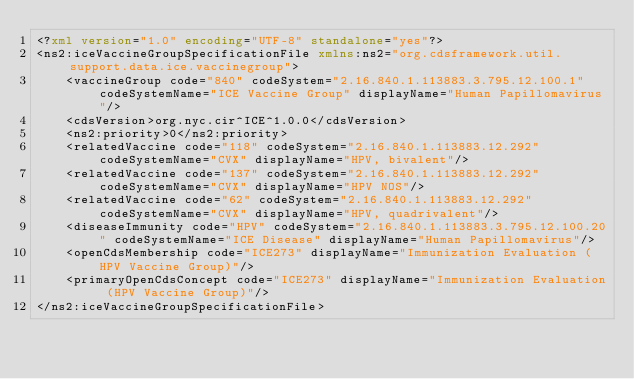Convert code to text. <code><loc_0><loc_0><loc_500><loc_500><_XML_><?xml version="1.0" encoding="UTF-8" standalone="yes"?>
<ns2:iceVaccineGroupSpecificationFile xmlns:ns2="org.cdsframework.util.support.data.ice.vaccinegroup">
    <vaccineGroup code="840" codeSystem="2.16.840.1.113883.3.795.12.100.1" codeSystemName="ICE Vaccine Group" displayName="Human Papillomavirus"/>
    <cdsVersion>org.nyc.cir^ICE^1.0.0</cdsVersion>
    <ns2:priority>0</ns2:priority>
    <relatedVaccine code="118" codeSystem="2.16.840.1.113883.12.292" codeSystemName="CVX" displayName="HPV, bivalent"/>
    <relatedVaccine code="137" codeSystem="2.16.840.1.113883.12.292" codeSystemName="CVX" displayName="HPV NOS"/>
    <relatedVaccine code="62" codeSystem="2.16.840.1.113883.12.292" codeSystemName="CVX" displayName="HPV, quadrivalent"/>
    <diseaseImmunity code="HPV" codeSystem="2.16.840.1.113883.3.795.12.100.20" codeSystemName="ICE Disease" displayName="Human Papillomavirus"/>
    <openCdsMembership code="ICE273" displayName="Immunization Evaluation (HPV Vaccine Group)"/>
    <primaryOpenCdsConcept code="ICE273" displayName="Immunization Evaluation (HPV Vaccine Group)"/>
</ns2:iceVaccineGroupSpecificationFile>
</code> 